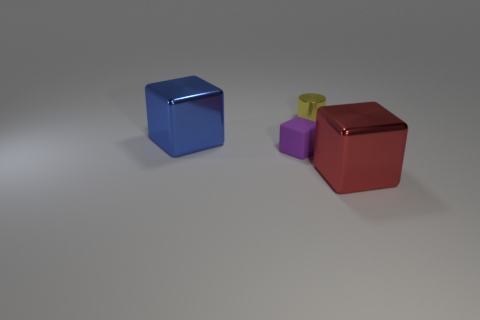Is there anything else that is made of the same material as the tiny purple object?
Keep it short and to the point. No. What number of large things are right of the purple rubber block and to the left of the purple matte object?
Offer a very short reply. 0. How many other objects are there of the same size as the purple object?
Provide a short and direct response. 1. There is a thing that is in front of the metallic cylinder and right of the small purple rubber thing; what material is it made of?
Offer a terse response. Metal. Is the color of the matte thing the same as the big metal cube that is left of the red shiny thing?
Your answer should be very brief. No. The other blue thing that is the same shape as the matte object is what size?
Keep it short and to the point. Large. What shape is the shiny object that is both in front of the yellow thing and to the left of the red object?
Give a very brief answer. Cube. Does the purple matte cube have the same size as the metal block that is on the left side of the red shiny object?
Your answer should be compact. No. There is another small thing that is the same shape as the red shiny thing; what color is it?
Your answer should be compact. Purple. Do the metallic object behind the blue thing and the metallic block to the right of the tiny yellow metallic thing have the same size?
Make the answer very short. No. 